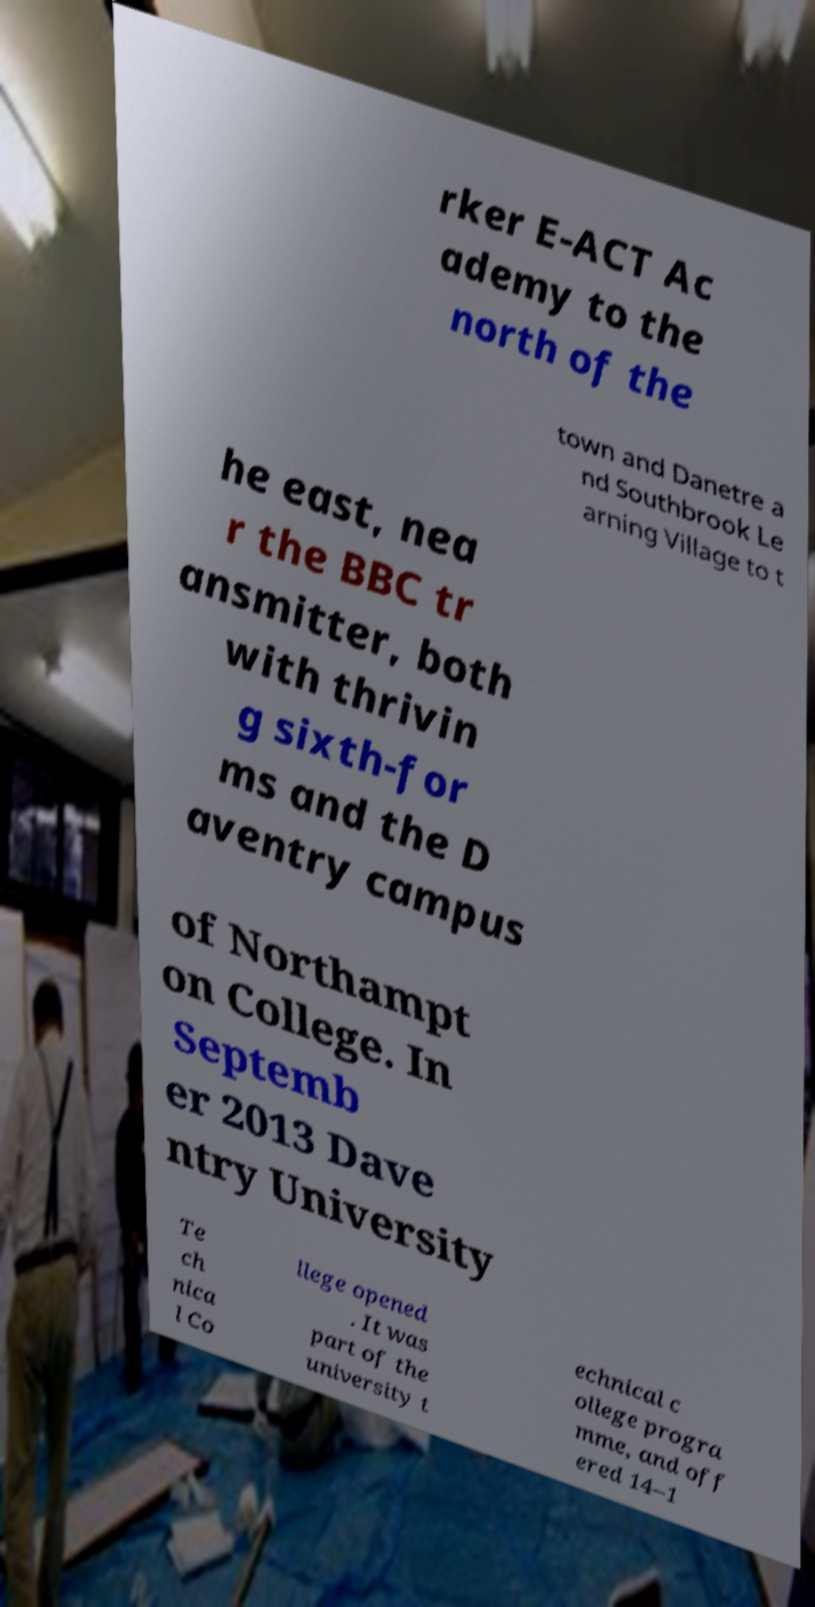What messages or text are displayed in this image? I need them in a readable, typed format. rker E-ACT Ac ademy to the north of the town and Danetre a nd Southbrook Le arning Village to t he east, nea r the BBC tr ansmitter, both with thrivin g sixth-for ms and the D aventry campus of Northampt on College. In Septemb er 2013 Dave ntry University Te ch nica l Co llege opened . It was part of the university t echnical c ollege progra mme, and off ered 14–1 